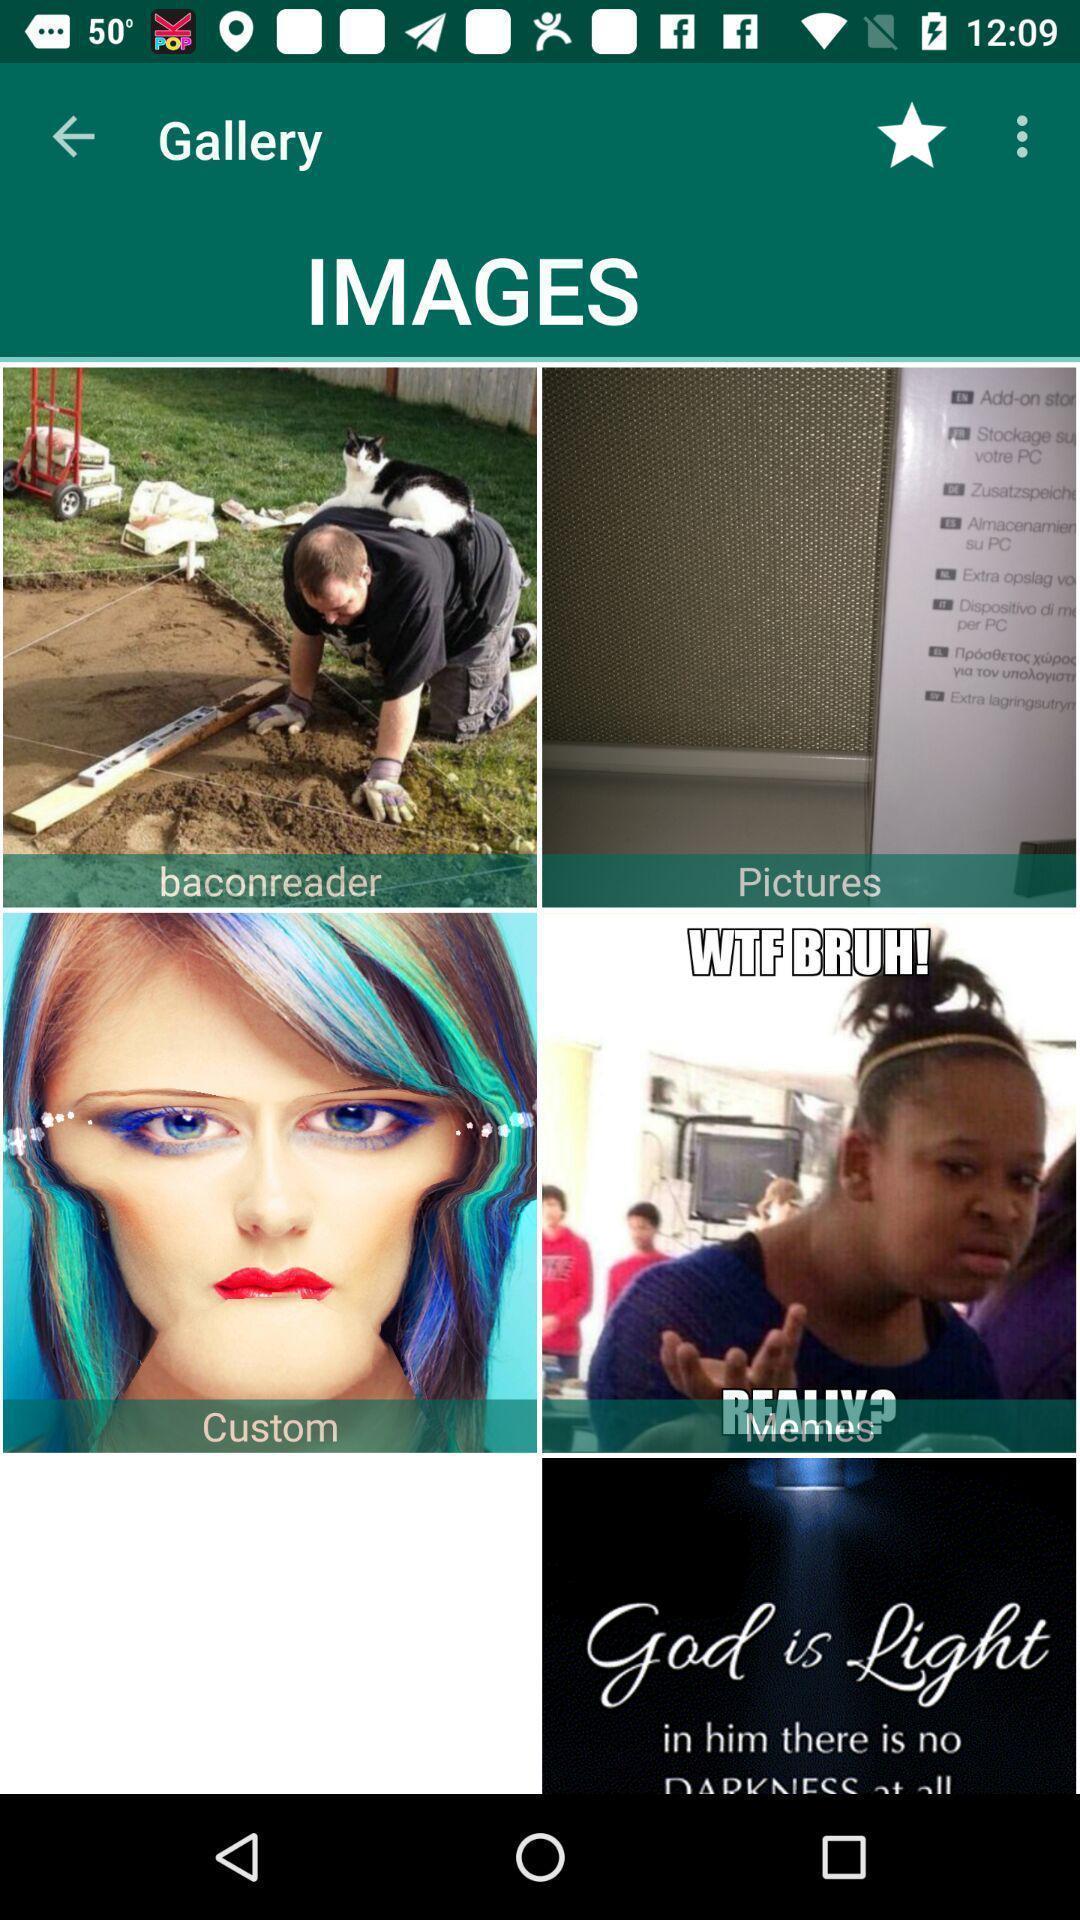Explain the elements present in this screenshot. Page displaying images in gallery for an app. 